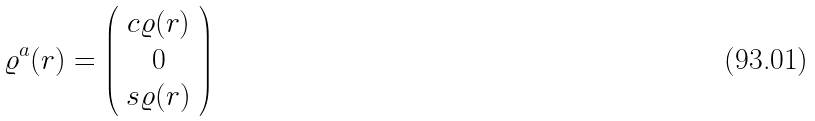<formula> <loc_0><loc_0><loc_500><loc_500>\varrho ^ { a } ( r ) = \left ( \begin{array} { c c } c \varrho ( r ) \\ 0 \\ s \varrho ( r ) \end{array} \right )</formula> 